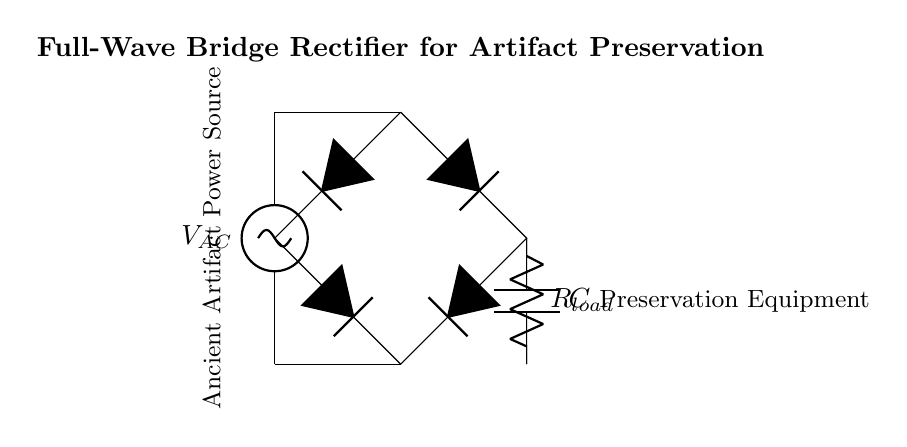What type of current does this circuit convert? The circuit converts alternating current into direct current, as a bridge rectifier is specifically designed to perform this conversion.
Answer: Direct current How many diodes are used in the bridge rectifier? The bridge rectifier consists of four diodes arranged in a specific configuration to allow the conversion of input AC into DC.
Answer: Four diodes What is the function of the capacitor in this circuit? The capacitor smooths out the variations in voltage that result from the rectification process, aiming to produce a more stable and constant output voltage for the preservation equipment.
Answer: Smoothing What is the role of the resistor labeled as R_load? The resistor serves as the load for the output of the rectifier, ensuring that the circuit can provide the necessary power to the preservation equipment connected to it.
Answer: Load resistor What is the orientation of the voltage source in the diagram? The voltage source is oriented vertically, indicating the supply of alternating voltage to the bridge rectifier.
Answer: Vertical How does the full-wave bridge rectifier improve efficiency compared to a half-wave rectifier? By using four diodes to allow both halves of the AC waveform to contribute to the output, the full-wave bridge rectifier provides a more efficient power conversion, resulting in higher average output voltage and better utilization of the input signal.
Answer: More efficient 